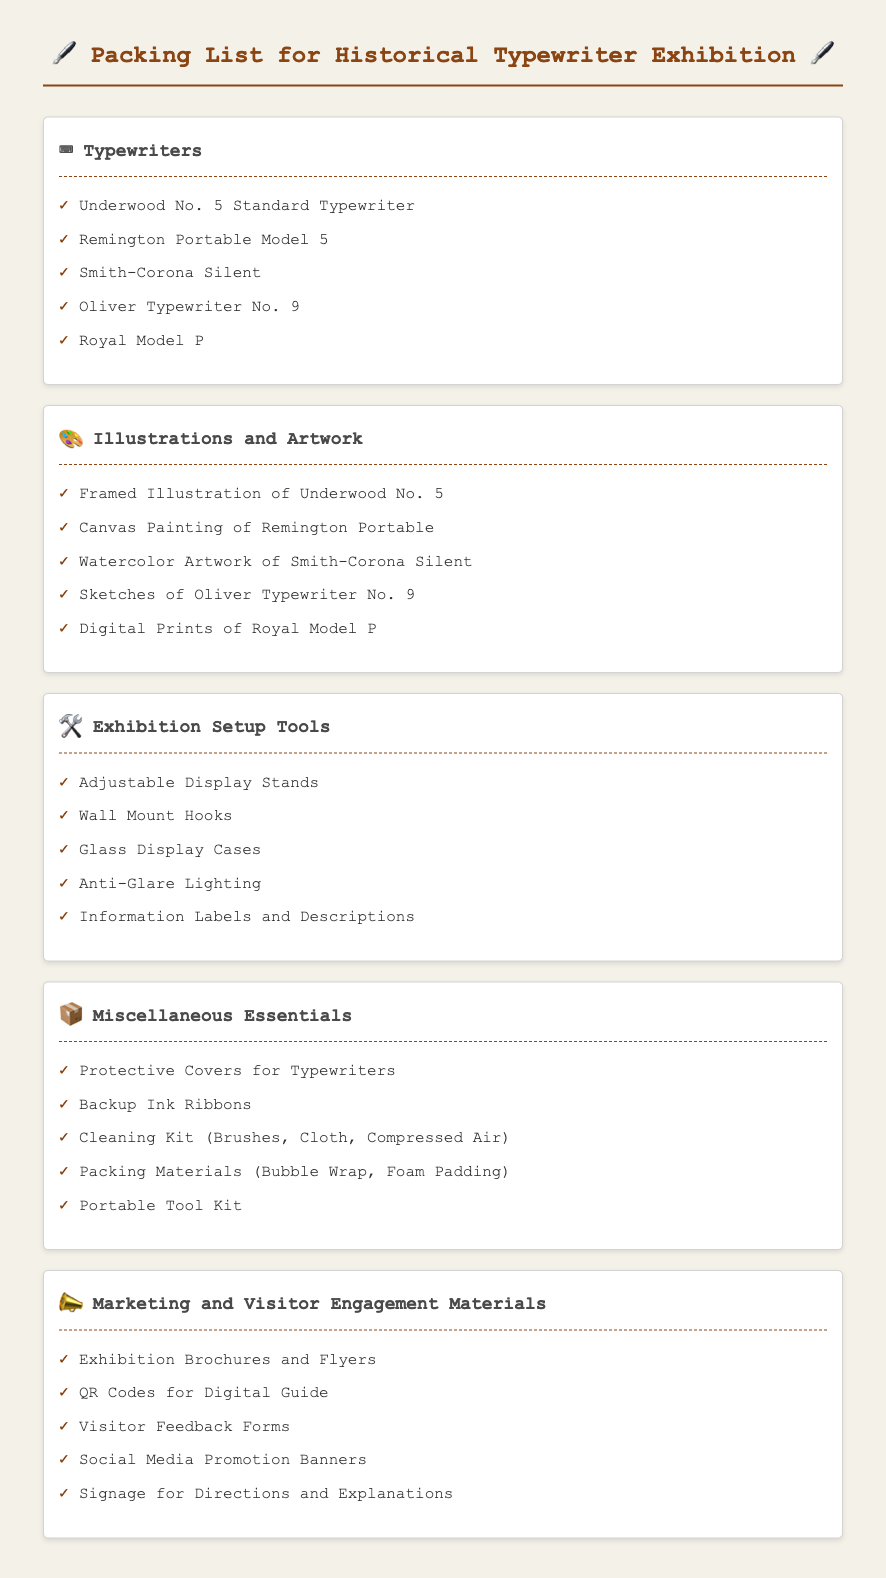What typewriter is listed first in the packing list? The first typewriter mentioned in the list of typewriters is the Underwood No. 5 Standard Typewriter.
Answer: Underwood No. 5 Standard Typewriter How many illustrations are mentioned in the document? The list under Illustrations and Artwork contains five different artworks.
Answer: 5 What is the purpose of the "Marketing and Visitor Engagement Materials" section? This section contains materials intended to engage visitors and promote the exhibition.
Answer: Engagement Which typewriter has a model number that contains the word 'Silent'? The typewriter with the word 'Silent' in its name is the Smith-Corona Silent.
Answer: Smith-Corona Silent How many items are listed under "Exhibition Setup Tools"? The section "Exhibition Setup Tools" contains a total of five items.
Answer: 5 What are the includes of "Miscellaneous Essentials"? The Miscellaneous Essentials section contains items that are necessary for handling typewriters, such as protective covers and cleaning kits.
Answer: Protective Covers for Typewriters, Backup Ink Ribbons, Cleaning Kit, Packing Materials, Portable Tool Kit What kind of artwork features the Remington Portable? The Remington Portable is represented as a Canvas Painting in the Illustrations and Artwork section.
Answer: Canvas Painting Which icon represents Typewriters in the document? The icon used to represent Typewriters is the keyboard symbol.
Answer: ⌨️ 